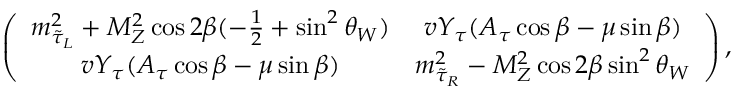Convert formula to latex. <formula><loc_0><loc_0><loc_500><loc_500>\left ( \begin{array} { c c } { { m _ { \tilde { \tau } _ { L } } ^ { 2 } + M _ { Z } ^ { 2 } \cos 2 \beta ( - \frac { 1 } { 2 } + \sin ^ { 2 } \theta _ { W } ) } } & { { v Y _ { \tau } ( A _ { \tau } \cos \beta - \mu \sin \beta ) } } \\ { { v Y _ { \tau } ( A _ { \tau } \cos \beta - \mu \sin \beta ) } } & { { m _ { \tilde { \tau } _ { R } } ^ { 2 } - M _ { Z } ^ { 2 } \cos 2 \beta \sin ^ { 2 } \theta _ { W } } } \end{array} \right ) ,</formula> 